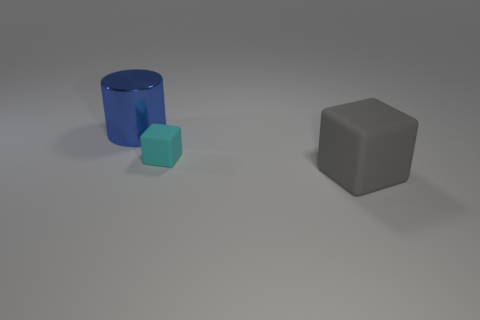Add 2 tiny yellow cylinders. How many objects exist? 5 Subtract all gray cubes. How many cubes are left? 1 Subtract all cylinders. How many objects are left? 2 Subtract 2 blocks. How many blocks are left? 0 Add 2 cubes. How many cubes are left? 4 Add 3 small yellow objects. How many small yellow objects exist? 3 Subtract 0 brown blocks. How many objects are left? 3 Subtract all yellow cubes. Subtract all blue cylinders. How many cubes are left? 2 Subtract all small brown rubber spheres. Subtract all big metallic cylinders. How many objects are left? 2 